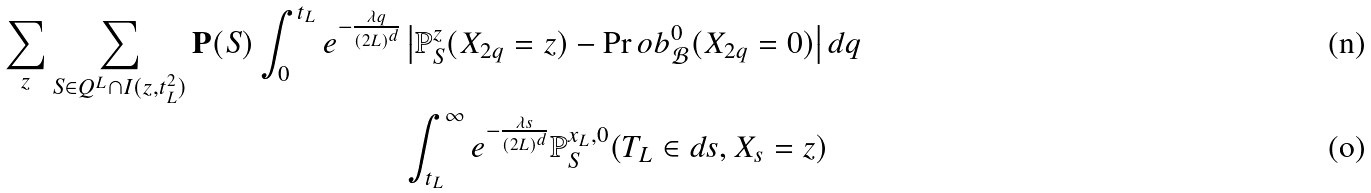<formula> <loc_0><loc_0><loc_500><loc_500>\sum _ { z } \sum _ { S \in Q ^ { L } \cap I ( z , t ^ { 2 } _ { L } ) } \mathbf P ( S ) \int _ { 0 } ^ { t _ { L } } e ^ { - \frac { \lambda q } { ( 2 L ) ^ { d } } } & \left | \mathbb { P } _ { S } ^ { z } ( X _ { 2 q } = z ) - \Pr o b _ { \mathcal { B } } ^ { 0 } ( X _ { 2 q } = 0 ) \right | d q \\ & \int _ { t _ { L } } ^ { \infty } e ^ { - \frac { \lambda s } { ( 2 L ) ^ { d } } } \mathbb { P } _ { S } ^ { x _ { L } , 0 } ( T _ { L } \in d s , X _ { s } = z )</formula> 